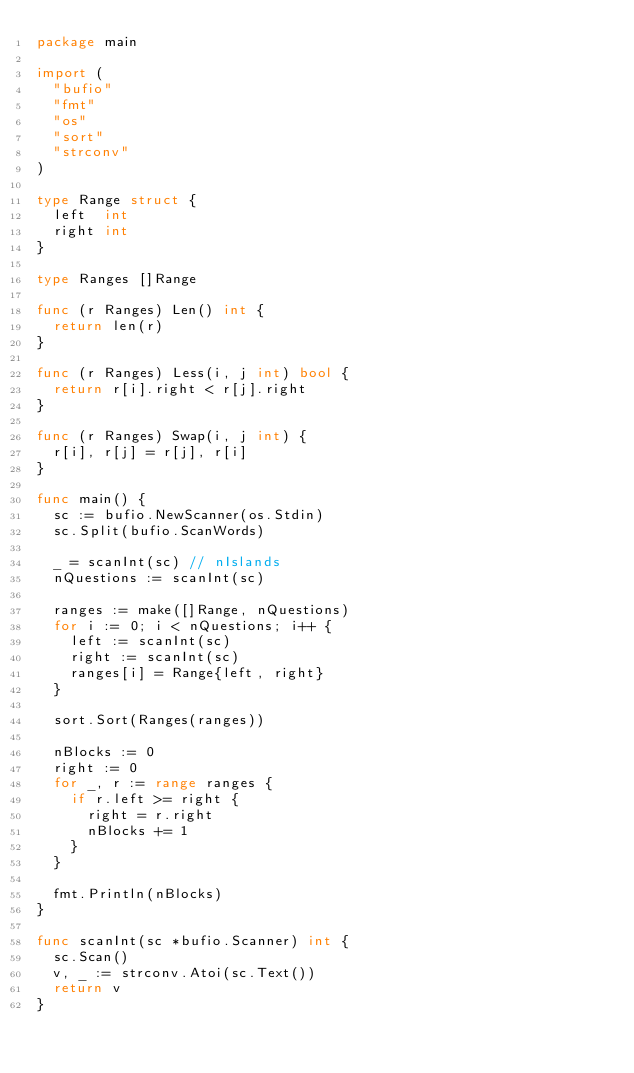Convert code to text. <code><loc_0><loc_0><loc_500><loc_500><_Go_>package main

import (
	"bufio"
	"fmt"
	"os"
	"sort"
	"strconv"
)

type Range struct {
	left  int
	right int
}

type Ranges []Range

func (r Ranges) Len() int {
	return len(r)
}

func (r Ranges) Less(i, j int) bool {
	return r[i].right < r[j].right
}

func (r Ranges) Swap(i, j int) {
	r[i], r[j] = r[j], r[i]
}

func main() {
	sc := bufio.NewScanner(os.Stdin)
	sc.Split(bufio.ScanWords)

	_ = scanInt(sc) // nIslands
	nQuestions := scanInt(sc)

	ranges := make([]Range, nQuestions)
	for i := 0; i < nQuestions; i++ {
		left := scanInt(sc)
		right := scanInt(sc)
		ranges[i] = Range{left, right}
	}

	sort.Sort(Ranges(ranges))

	nBlocks := 0
	right := 0
	for _, r := range ranges {
		if r.left >= right {
			right = r.right
			nBlocks += 1
		}
	}

	fmt.Println(nBlocks)
}

func scanInt(sc *bufio.Scanner) int {
	sc.Scan()
	v, _ := strconv.Atoi(sc.Text())
	return v
}
</code> 